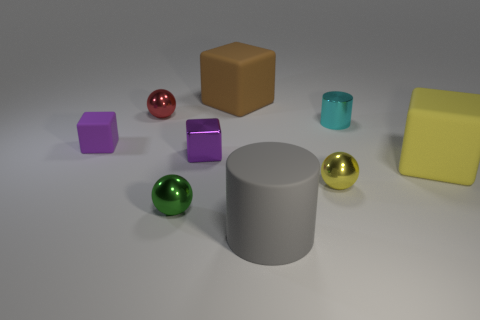Is the color of the metal block the same as the small rubber block?
Give a very brief answer. Yes. The matte thing that is the same color as the metallic cube is what size?
Make the answer very short. Small. There is a large rubber thing that is both in front of the tiny metallic block and on the left side of the big yellow matte object; what is its shape?
Give a very brief answer. Cylinder. What size is the cyan object that is the same shape as the gray matte thing?
Give a very brief answer. Small. Is the number of metallic spheres that are to the left of the purple metal thing less than the number of large brown objects?
Your answer should be compact. No. How big is the cylinder that is in front of the large yellow thing?
Make the answer very short. Large. There is another large matte object that is the same shape as the large yellow object; what color is it?
Make the answer very short. Brown. What number of large things are the same color as the large cylinder?
Offer a very short reply. 0. Is there anything else that has the same shape as the gray object?
Offer a terse response. Yes. Are there any tiny green spheres that are in front of the big block that is in front of the matte block that is behind the red object?
Your response must be concise. Yes. 